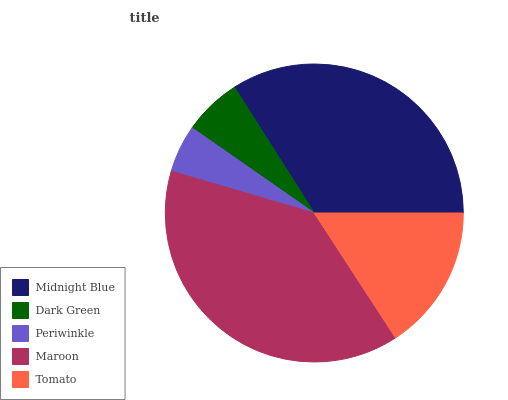Is Periwinkle the minimum?
Answer yes or no. Yes. Is Maroon the maximum?
Answer yes or no. Yes. Is Dark Green the minimum?
Answer yes or no. No. Is Dark Green the maximum?
Answer yes or no. No. Is Midnight Blue greater than Dark Green?
Answer yes or no. Yes. Is Dark Green less than Midnight Blue?
Answer yes or no. Yes. Is Dark Green greater than Midnight Blue?
Answer yes or no. No. Is Midnight Blue less than Dark Green?
Answer yes or no. No. Is Tomato the high median?
Answer yes or no. Yes. Is Tomato the low median?
Answer yes or no. Yes. Is Maroon the high median?
Answer yes or no. No. Is Maroon the low median?
Answer yes or no. No. 